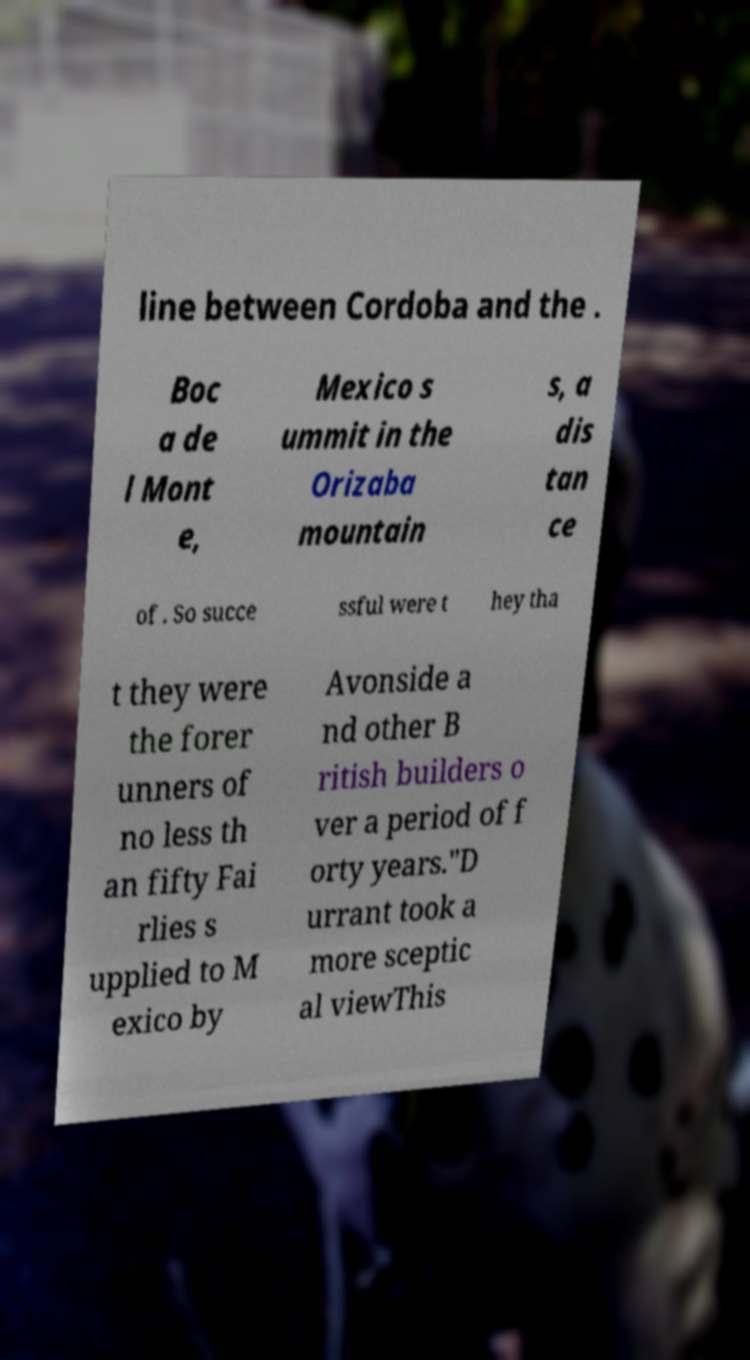What messages or text are displayed in this image? I need them in a readable, typed format. line between Cordoba and the . Boc a de l Mont e, Mexico s ummit in the Orizaba mountain s, a dis tan ce of . So succe ssful were t hey tha t they were the forer unners of no less th an fifty Fai rlies s upplied to M exico by Avonside a nd other B ritish builders o ver a period of f orty years."D urrant took a more sceptic al viewThis 